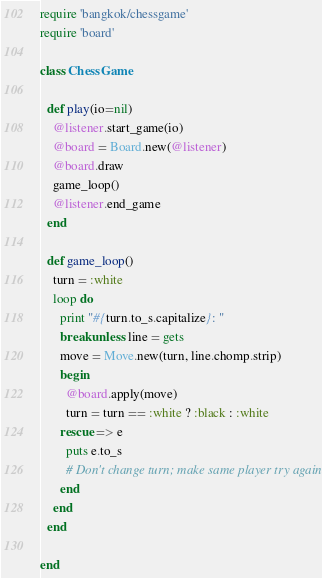Convert code to text. <code><loc_0><loc_0><loc_500><loc_500><_Ruby_>require 'bangkok/chessgame'
require 'board'

class ChessGame

  def play(io=nil)
    @listener.start_game(io)
    @board = Board.new(@listener)
    @board.draw
    game_loop()
    @listener.end_game
  end

  def game_loop()
    turn = :white
    loop do
      print "#{turn.to_s.capitalize}: "
      break unless line = gets
      move = Move.new(turn, line.chomp.strip)
      begin
        @board.apply(move)
        turn = turn == :white ? :black : :white
      rescue => e
        puts e.to_s
        # Don't change turn; make same player try again
      end
    end
  end

end
</code> 